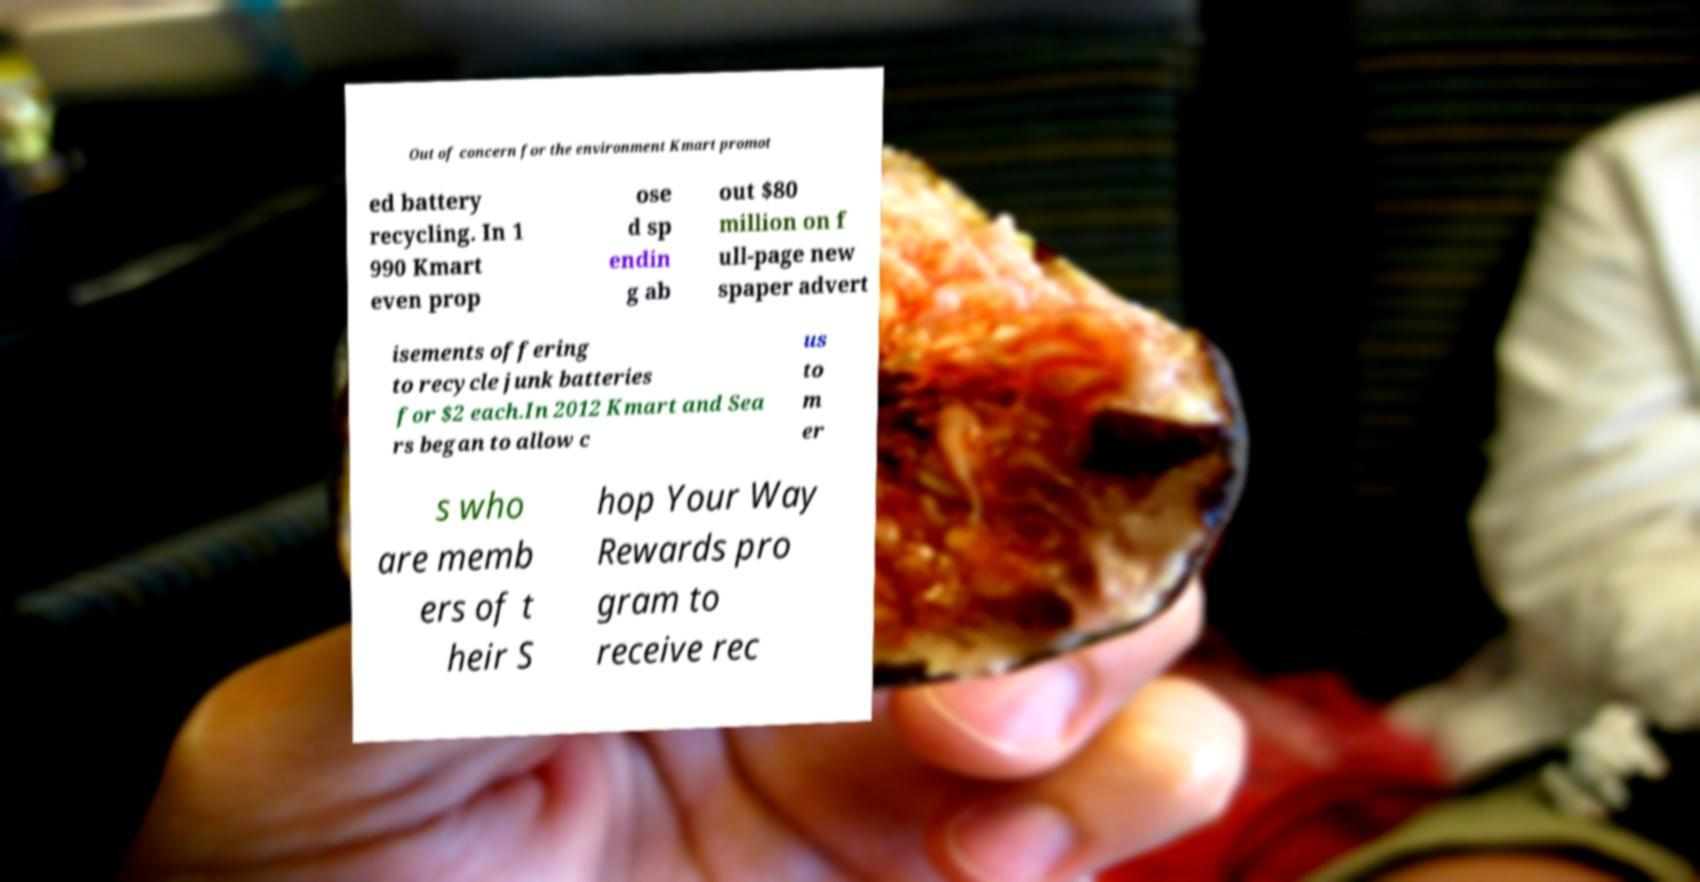Could you assist in decoding the text presented in this image and type it out clearly? Out of concern for the environment Kmart promot ed battery recycling. In 1 990 Kmart even prop ose d sp endin g ab out $80 million on f ull-page new spaper advert isements offering to recycle junk batteries for $2 each.In 2012 Kmart and Sea rs began to allow c us to m er s who are memb ers of t heir S hop Your Way Rewards pro gram to receive rec 